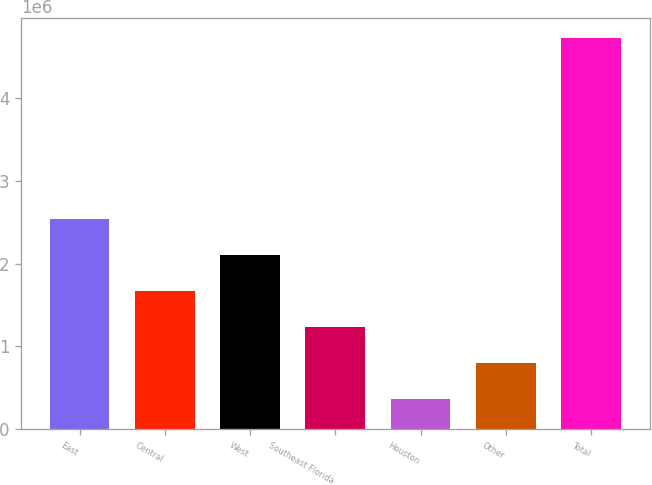<chart> <loc_0><loc_0><loc_500><loc_500><bar_chart><fcel>East<fcel>Central<fcel>West<fcel>Southeast Florida<fcel>Houston<fcel>Other<fcel>Total<nl><fcel>2.54331e+06<fcel>1.66878e+06<fcel>2.10604e+06<fcel>1.23151e+06<fcel>356971<fcel>794240<fcel>4.72966e+06<nl></chart> 